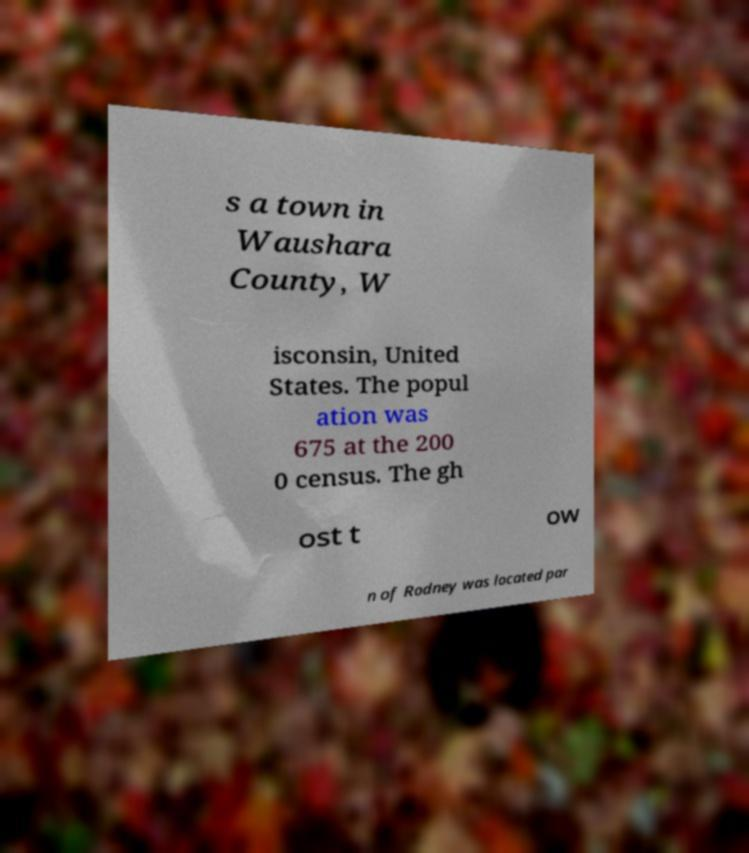For documentation purposes, I need the text within this image transcribed. Could you provide that? s a town in Waushara County, W isconsin, United States. The popul ation was 675 at the 200 0 census. The gh ost t ow n of Rodney was located par 